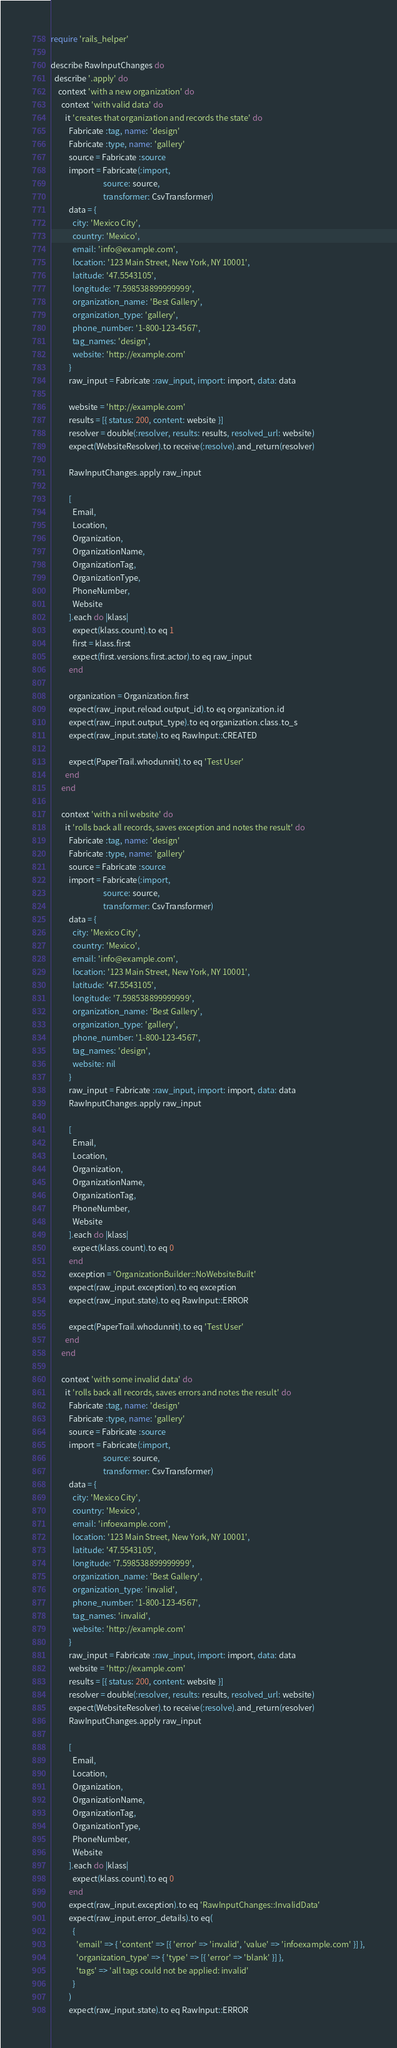Convert code to text. <code><loc_0><loc_0><loc_500><loc_500><_Ruby_>require 'rails_helper'

describe RawInputChanges do
  describe '.apply' do
    context 'with a new organization' do
      context 'with valid data' do
        it 'creates that organization and records the state' do
          Fabricate :tag, name: 'design'
          Fabricate :type, name: 'gallery'
          source = Fabricate :source
          import = Fabricate(:import,
                             source: source,
                             transformer: CsvTransformer)
          data = {
            city: 'Mexico City',
            country: 'Mexico',
            email: 'info@example.com',
            location: '123 Main Street, New York, NY 10001',
            latitude: '47.5543105',
            longitude: '7.598538899999999',
            organization_name: 'Best Gallery',
            organization_type: 'gallery',
            phone_number: '1-800-123-4567',
            tag_names: 'design',
            website: 'http://example.com'
          }
          raw_input = Fabricate :raw_input, import: import, data: data

          website = 'http://example.com'
          results = [{ status: 200, content: website }]
          resolver = double(:resolver, results: results, resolved_url: website)
          expect(WebsiteResolver).to receive(:resolve).and_return(resolver)

          RawInputChanges.apply raw_input

          [
            Email,
            Location,
            Organization,
            OrganizationName,
            OrganizationTag,
            OrganizationType,
            PhoneNumber,
            Website
          ].each do |klass|
            expect(klass.count).to eq 1
            first = klass.first
            expect(first.versions.first.actor).to eq raw_input
          end

          organization = Organization.first
          expect(raw_input.reload.output_id).to eq organization.id
          expect(raw_input.output_type).to eq organization.class.to_s
          expect(raw_input.state).to eq RawInput::CREATED

          expect(PaperTrail.whodunnit).to eq 'Test User'
        end
      end

      context 'with a nil website' do
        it 'rolls back all records, saves exception and notes the result' do
          Fabricate :tag, name: 'design'
          Fabricate :type, name: 'gallery'
          source = Fabricate :source
          import = Fabricate(:import,
                             source: source,
                             transformer: CsvTransformer)
          data = {
            city: 'Mexico City',
            country: 'Mexico',
            email: 'info@example.com',
            location: '123 Main Street, New York, NY 10001',
            latitude: '47.5543105',
            longitude: '7.598538899999999',
            organization_name: 'Best Gallery',
            organization_type: 'gallery',
            phone_number: '1-800-123-4567',
            tag_names: 'design',
            website: nil
          }
          raw_input = Fabricate :raw_input, import: import, data: data
          RawInputChanges.apply raw_input

          [
            Email,
            Location,
            Organization,
            OrganizationName,
            OrganizationTag,
            PhoneNumber,
            Website
          ].each do |klass|
            expect(klass.count).to eq 0
          end
          exception = 'OrganizationBuilder::NoWebsiteBuilt'
          expect(raw_input.exception).to eq exception
          expect(raw_input.state).to eq RawInput::ERROR

          expect(PaperTrail.whodunnit).to eq 'Test User'
        end
      end

      context 'with some invalid data' do
        it 'rolls back all records, saves errors and notes the result' do
          Fabricate :tag, name: 'design'
          Fabricate :type, name: 'gallery'
          source = Fabricate :source
          import = Fabricate(:import,
                             source: source,
                             transformer: CsvTransformer)
          data = {
            city: 'Mexico City',
            country: 'Mexico',
            email: 'infoexample.com',
            location: '123 Main Street, New York, NY 10001',
            latitude: '47.5543105',
            longitude: '7.598538899999999',
            organization_name: 'Best Gallery',
            organization_type: 'invalid',
            phone_number: '1-800-123-4567',
            tag_names: 'invalid',
            website: 'http://example.com'
          }
          raw_input = Fabricate :raw_input, import: import, data: data
          website = 'http://example.com'
          results = [{ status: 200, content: website }]
          resolver = double(:resolver, results: results, resolved_url: website)
          expect(WebsiteResolver).to receive(:resolve).and_return(resolver)
          RawInputChanges.apply raw_input

          [
            Email,
            Location,
            Organization,
            OrganizationName,
            OrganizationTag,
            OrganizationType,
            PhoneNumber,
            Website
          ].each do |klass|
            expect(klass.count).to eq 0
          end
          expect(raw_input.exception).to eq 'RawInputChanges::InvalidData'
          expect(raw_input.error_details).to eq(
            {
              'email' => { 'content' => [{ 'error' => 'invalid', 'value' => 'infoexample.com' }] },
              'organization_type' => { 'type' => [{ 'error' => 'blank' }] },
              'tags' => 'all tags could not be applied: invalid'
            }
          )
          expect(raw_input.state).to eq RawInput::ERROR
</code> 